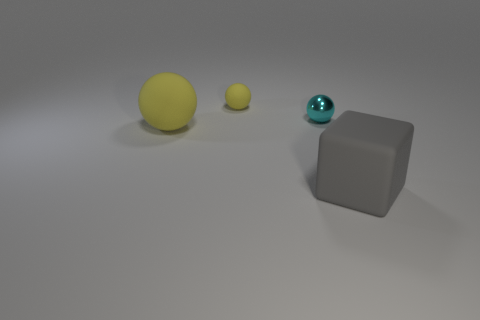How would you describe the mood or atmosphere of this image? The image conveys a calm and minimalist atmosphere. The soft lighting combined with the simple arrangement of the objects creates a sense of tranquility. The neutral background together with the matte surface of the cube and the soft hues of the spheres contribute to a serene and uncluttered visual experience. 